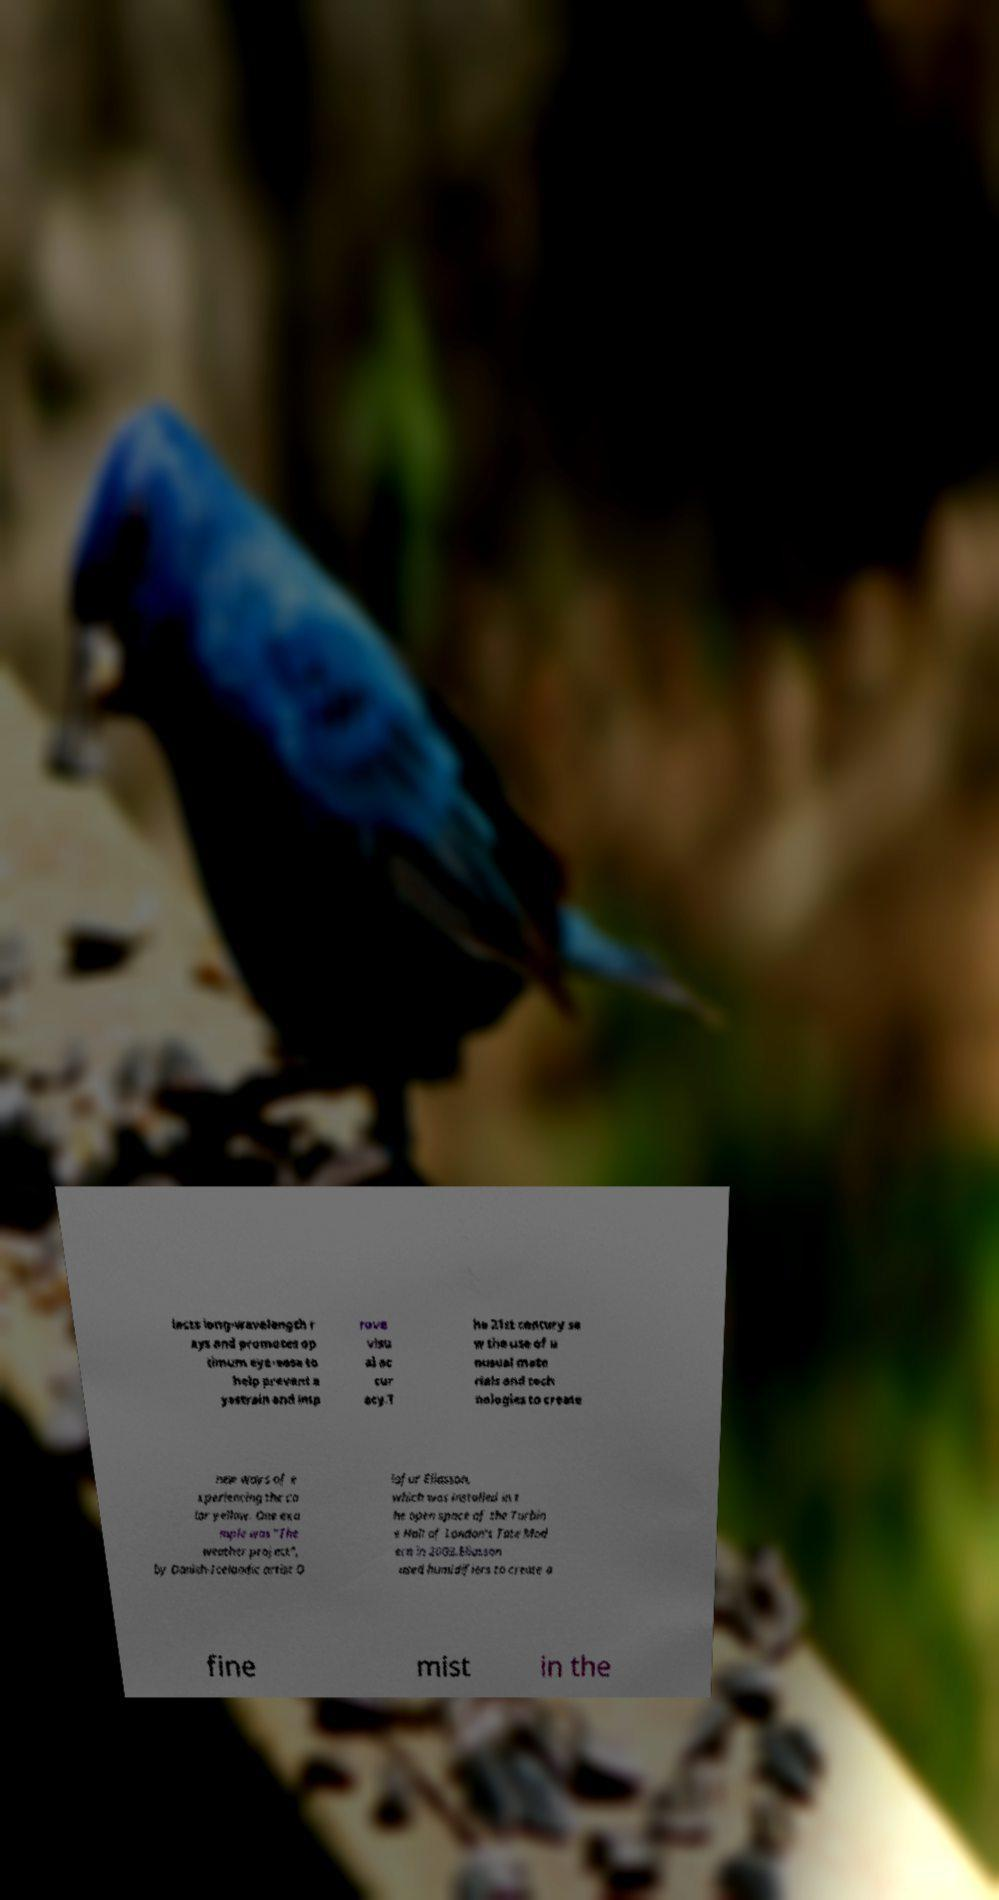There's text embedded in this image that I need extracted. Can you transcribe it verbatim? lects long-wavelength r ays and promotes op timum eye-ease to help prevent e yestrain and imp rove visu al ac cur acy.T he 21st century sa w the use of u nusual mate rials and tech nologies to create new ways of e xperiencing the co lor yellow. One exa mple was "The weather project", by Danish-Icelandic artist O lafur Eliasson, which was installed in t he open space of the Turbin e Hall of London's Tate Mod ern in 2003.Eliasson used humidifiers to create a fine mist in the 